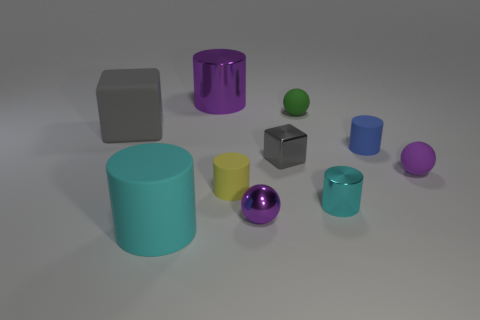The cylinder that is right of the small purple metallic sphere and in front of the small gray metal block is what color?
Give a very brief answer. Cyan. What color is the large thing on the right side of the cyan cylinder to the left of the green matte object behind the small yellow rubber cylinder?
Provide a short and direct response. Purple. What is the color of the block that is the same size as the purple rubber sphere?
Provide a succinct answer. Gray. What shape is the small purple shiny thing on the right side of the rubber cylinder left of the cylinder behind the small blue object?
Your answer should be very brief. Sphere. What shape is the tiny thing that is the same color as the tiny shiny sphere?
Make the answer very short. Sphere. How many objects are either tiny shiny blocks or big gray matte objects that are on the left side of the purple cylinder?
Make the answer very short. 2. Does the metal cylinder left of the green sphere have the same size as the green object?
Your answer should be very brief. No. There is a small purple object that is behind the tiny cyan object; what is its material?
Provide a succinct answer. Rubber. Is the number of purple metal cylinders that are behind the small gray metal thing the same as the number of cyan rubber things that are behind the yellow cylinder?
Provide a succinct answer. No. There is a small metallic object that is the same shape as the big cyan matte object; what is its color?
Make the answer very short. Cyan. 